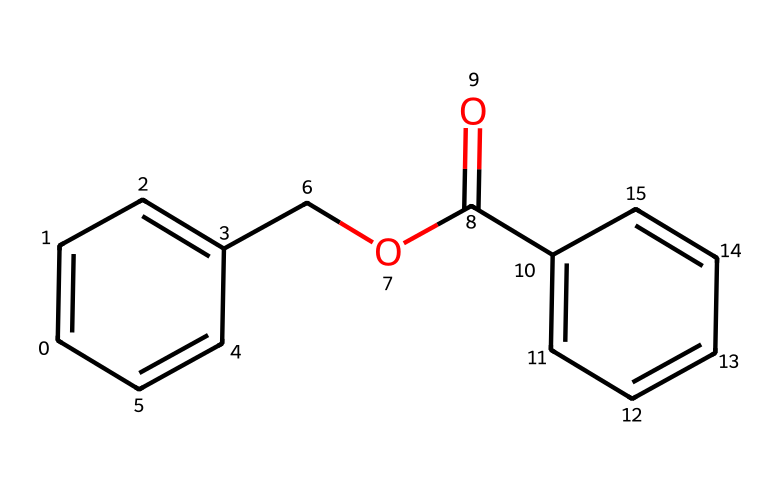What is the name of this chemical? The SMILES representation indicates that this compound has a structure consisting of a benzyl group attached to a benzoate moiety, which is characteristic of benzyl benzoate.
Answer: benzyl benzoate How many carbon atoms are present in the structure? Analyzing the SMILES representation, we count 15 carbon atoms in total forming the aromatic rings and the ester group.
Answer: 15 What type of functional group is present in this chemical? The presence of the carbon-oxygen double bond (C=O) and the carbon-oxygen single bond (C-O) indicates the existence of an ester functional group within the structure.
Answer: ester What is the total number of rings in this molecule? The SMILES shows two aromatic rings in the structure, which are indicated by the alternating double bonds, confirming the presence of 2 rings overall.
Answer: 2 What type of compound is benzyl benzoate classified as? Due to the presence of an aromatic hydrocarbon and the ester functional group, benzyl benzoate is classified as an aromatic ester.
Answer: aromatic ester How many oxygen atoms are present in the structure? Examining the SMILES reveals there are 2 oxygen atoms in the molecule, one in the carbonyl (C=O) and one in the ether (C-O) part of the ester.
Answer: 2 What property makes benzyl benzoate useful in anti-itch creams? The non-irritating properties and its ability to provide a soothing effect due to its aromatic structure contribute to its use in anti-itch creams.
Answer: soothing 